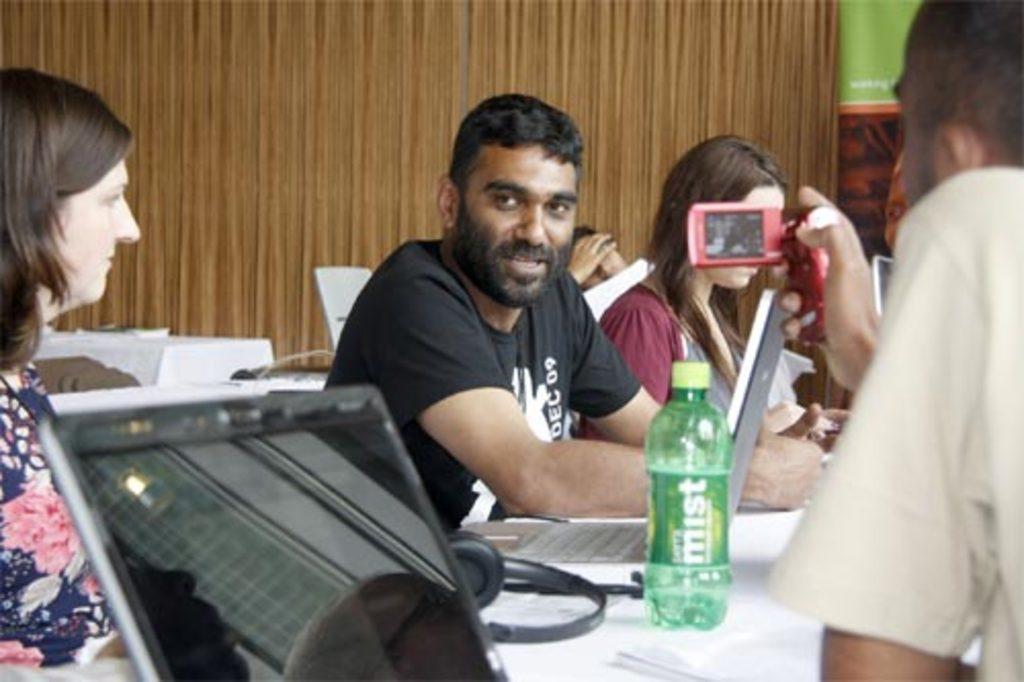How would you summarize this image in a sentence or two? There are few people here sitting on the chair. there is a laptop here on the table and a bottle. On the right a person is recording video. This is the wall. 